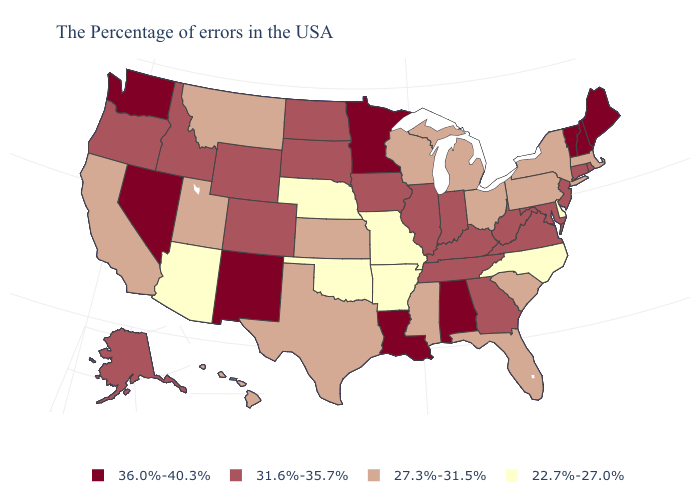Name the states that have a value in the range 27.3%-31.5%?
Write a very short answer. Massachusetts, New York, Pennsylvania, South Carolina, Ohio, Florida, Michigan, Wisconsin, Mississippi, Kansas, Texas, Utah, Montana, California, Hawaii. What is the value of Florida?
Keep it brief. 27.3%-31.5%. What is the highest value in the USA?
Answer briefly. 36.0%-40.3%. What is the highest value in the USA?
Give a very brief answer. 36.0%-40.3%. Name the states that have a value in the range 31.6%-35.7%?
Keep it brief. Rhode Island, Connecticut, New Jersey, Maryland, Virginia, West Virginia, Georgia, Kentucky, Indiana, Tennessee, Illinois, Iowa, South Dakota, North Dakota, Wyoming, Colorado, Idaho, Oregon, Alaska. Name the states that have a value in the range 36.0%-40.3%?
Be succinct. Maine, New Hampshire, Vermont, Alabama, Louisiana, Minnesota, New Mexico, Nevada, Washington. Among the states that border Wyoming , which have the lowest value?
Be succinct. Nebraska. Name the states that have a value in the range 22.7%-27.0%?
Write a very short answer. Delaware, North Carolina, Missouri, Arkansas, Nebraska, Oklahoma, Arizona. Name the states that have a value in the range 27.3%-31.5%?
Write a very short answer. Massachusetts, New York, Pennsylvania, South Carolina, Ohio, Florida, Michigan, Wisconsin, Mississippi, Kansas, Texas, Utah, Montana, California, Hawaii. Name the states that have a value in the range 31.6%-35.7%?
Short answer required. Rhode Island, Connecticut, New Jersey, Maryland, Virginia, West Virginia, Georgia, Kentucky, Indiana, Tennessee, Illinois, Iowa, South Dakota, North Dakota, Wyoming, Colorado, Idaho, Oregon, Alaska. What is the value of Wisconsin?
Quick response, please. 27.3%-31.5%. Name the states that have a value in the range 27.3%-31.5%?
Give a very brief answer. Massachusetts, New York, Pennsylvania, South Carolina, Ohio, Florida, Michigan, Wisconsin, Mississippi, Kansas, Texas, Utah, Montana, California, Hawaii. Name the states that have a value in the range 36.0%-40.3%?
Quick response, please. Maine, New Hampshire, Vermont, Alabama, Louisiana, Minnesota, New Mexico, Nevada, Washington. Does New York have the highest value in the Northeast?
Give a very brief answer. No. Among the states that border South Dakota , which have the lowest value?
Answer briefly. Nebraska. 